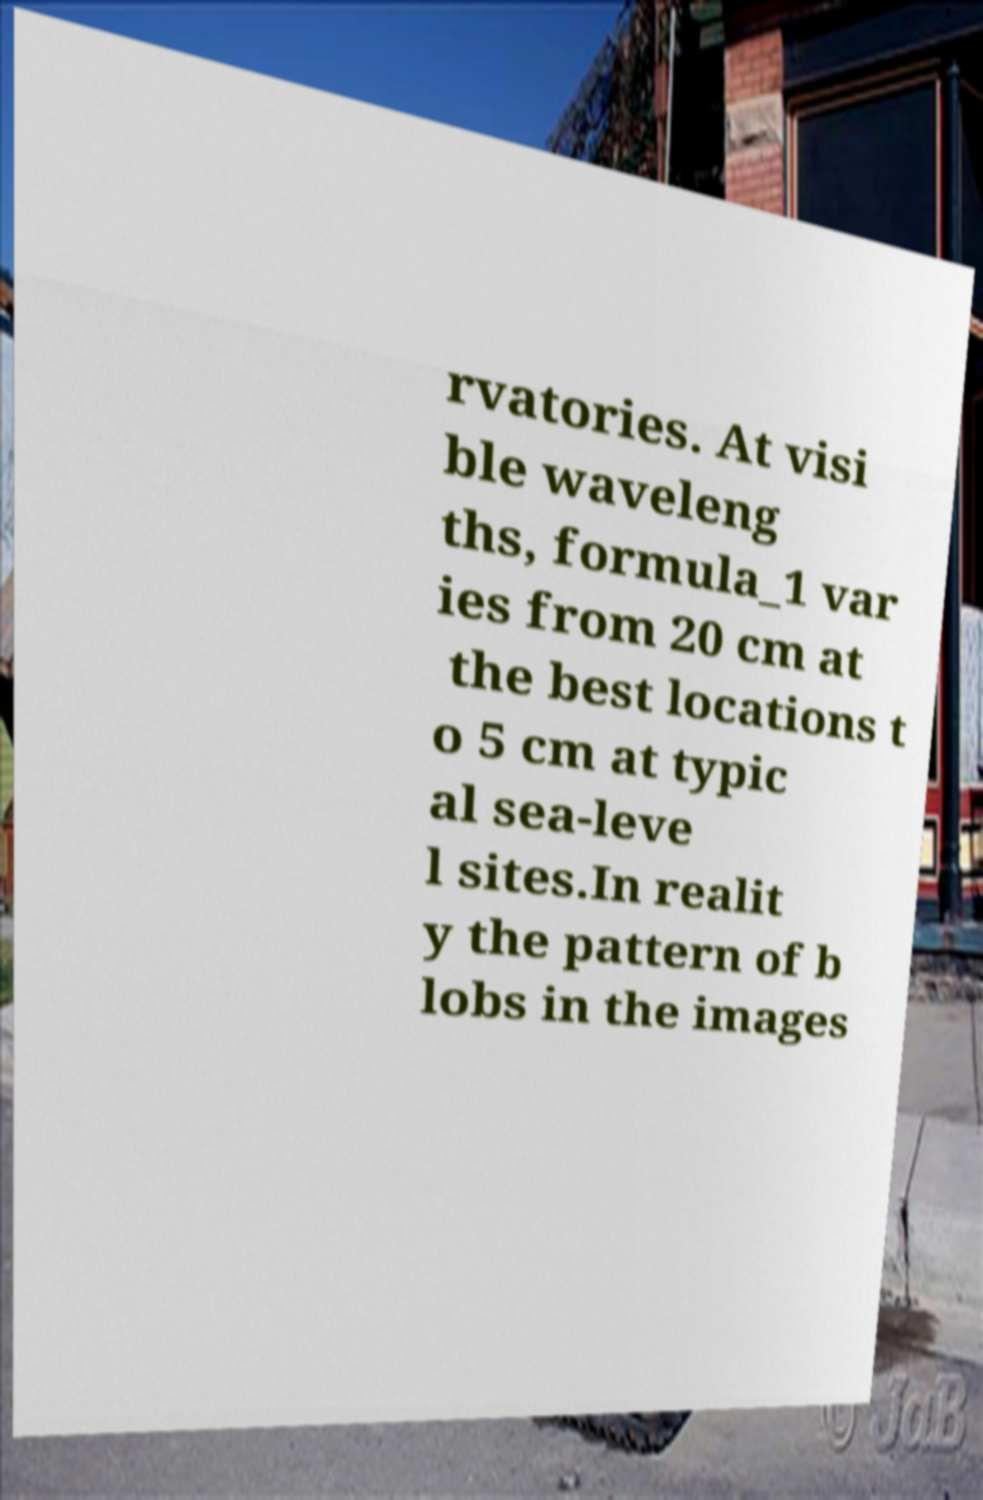Could you assist in decoding the text presented in this image and type it out clearly? rvatories. At visi ble waveleng ths, formula_1 var ies from 20 cm at the best locations t o 5 cm at typic al sea-leve l sites.In realit y the pattern of b lobs in the images 